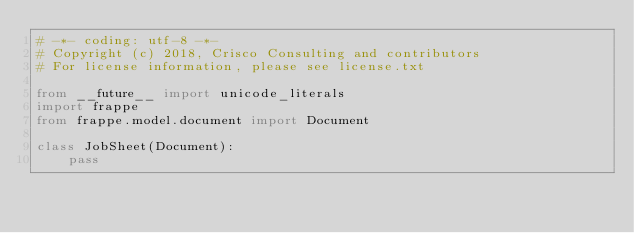<code> <loc_0><loc_0><loc_500><loc_500><_Python_># -*- coding: utf-8 -*-
# Copyright (c) 2018, Crisco Consulting and contributors
# For license information, please see license.txt

from __future__ import unicode_literals
import frappe
from frappe.model.document import Document

class JobSheet(Document):
	pass
</code> 